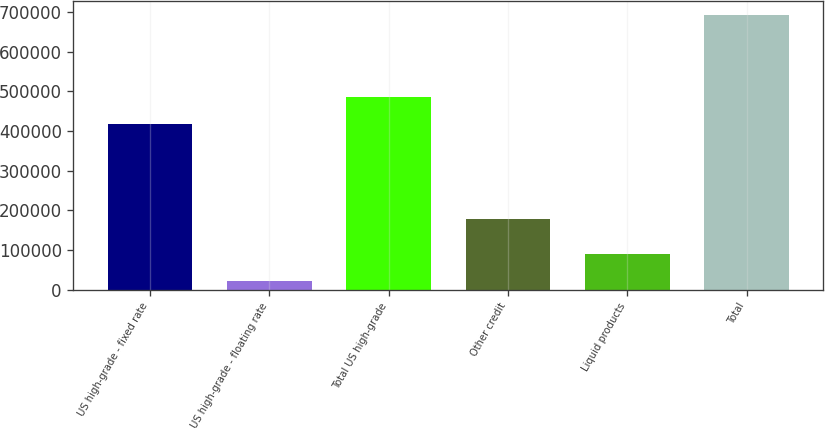Convert chart to OTSL. <chart><loc_0><loc_0><loc_500><loc_500><bar_chart><fcel>US high-grade - fixed rate<fcel>US high-grade - floating rate<fcel>Total US high-grade<fcel>Other credit<fcel>Liquid products<fcel>Total<nl><fcel>418270<fcel>21813<fcel>485456<fcel>177274<fcel>88999.3<fcel>693676<nl></chart> 